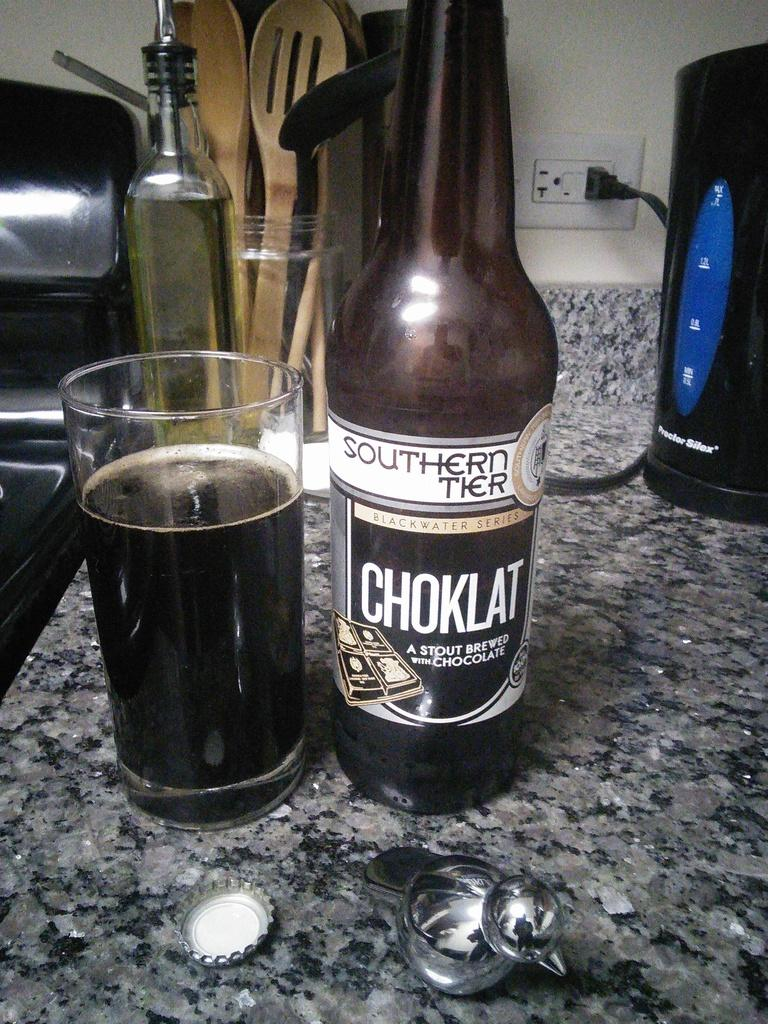Provide a one-sentence caption for the provided image. Sitting on a marble, top table is a bottle of Choklate, stout brewed  ale is shown, along with a glass of the ale. 